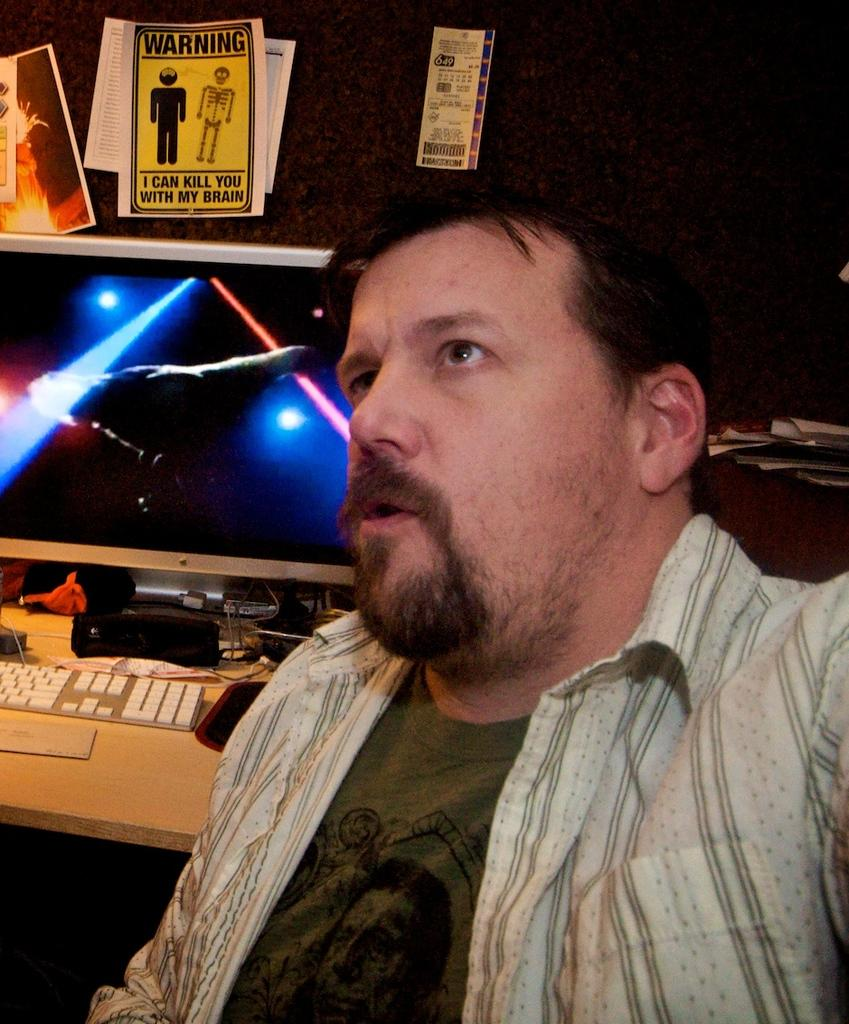Who is present in the image? There is a man in the image. What is located behind the man? There is a monitor and a keyboard behind the man. Are there any other objects visible behind the man? Yes, there are other objects behind the man. What type of flower is growing on the man's sweater in the image? There is no flower or sweater present in the image; the man is not wearing any clothing, and there is no mention of flowers. 